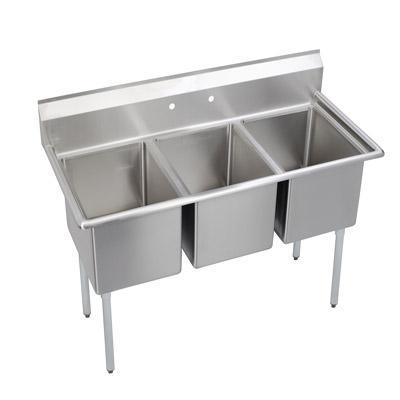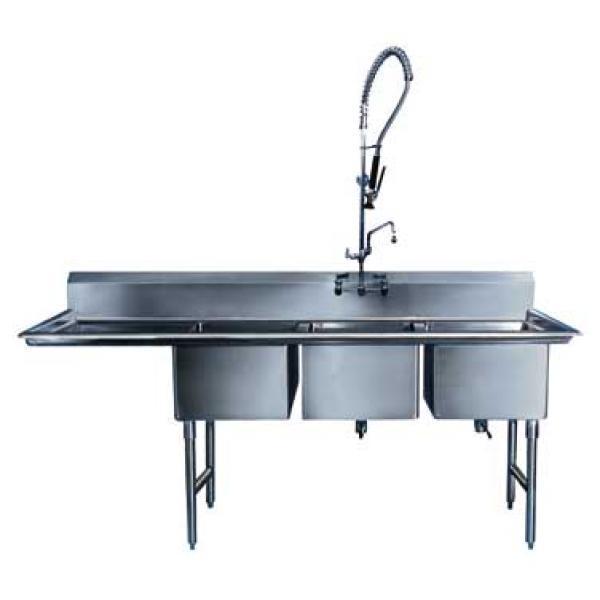The first image is the image on the left, the second image is the image on the right. For the images shown, is this caption "In at least one image there is a three basin sink with a a long left washing counter." true? Answer yes or no. Yes. The first image is the image on the left, the second image is the image on the right. Evaluate the accuracy of this statement regarding the images: "Each image contains a three part sink without a faucet". Is it true? Answer yes or no. No. 